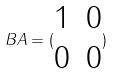Convert formula to latex. <formula><loc_0><loc_0><loc_500><loc_500>B A = ( \begin{matrix} 1 & 0 \\ 0 & 0 \end{matrix} )</formula> 